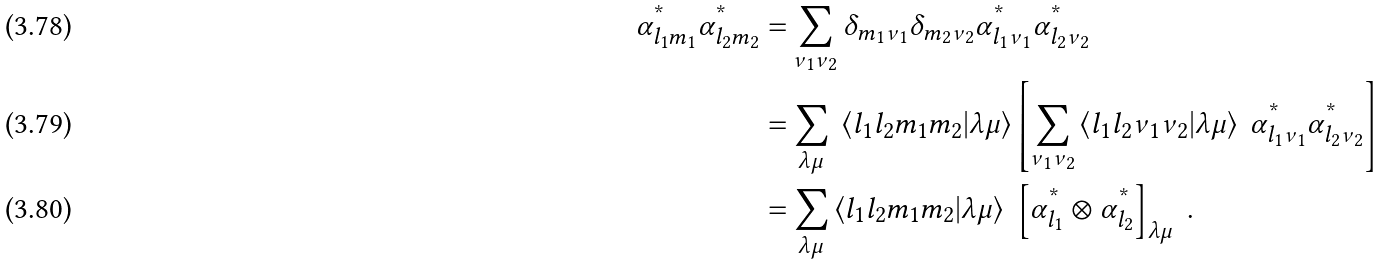<formula> <loc_0><loc_0><loc_500><loc_500>\alpha _ { l _ { 1 } m _ { 1 } } ^ { ^ { * } } \alpha _ { l _ { 2 } m _ { 2 } } ^ { ^ { * } } = & \sum _ { \nu _ { 1 } \nu _ { 2 } } \delta _ { m _ { 1 } \nu _ { 1 } } \delta _ { m _ { 2 } \nu _ { 2 } } \alpha _ { l _ { 1 } \nu _ { 1 } } ^ { ^ { * } } \alpha _ { l _ { 2 } \nu _ { 2 } } ^ { ^ { * } } \\ = & \sum _ { \lambda \mu } \ \left < l _ { 1 } l _ { 2 } m _ { 1 } m _ { 2 } | \lambda \mu \right > \left [ \sum _ { \nu _ { 1 } \nu _ { 2 } } \left < l _ { 1 } l _ { 2 } \nu _ { 1 } \nu _ { 2 } | \lambda \mu \right > \ \alpha _ { l _ { 1 } \nu _ { 1 } } ^ { ^ { * } } \alpha _ { l _ { 2 } \nu _ { 2 } } ^ { ^ { * } } \right ] \\ = & \sum _ { \lambda \mu } \left < l _ { 1 } l _ { 2 } m _ { 1 } m _ { 2 } | \lambda \mu \right > \ \left [ \alpha _ { l _ { 1 } } ^ { ^ { * } } \otimes \alpha _ { l _ { 2 } } ^ { ^ { * } } \right ] _ { \lambda \mu } \ .</formula> 